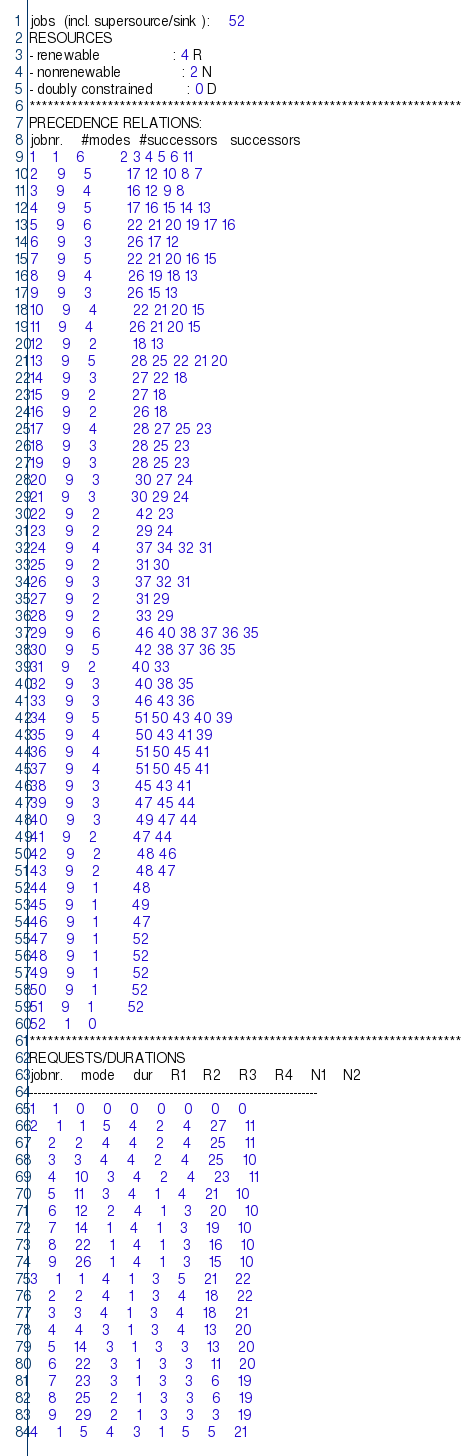Convert code to text. <code><loc_0><loc_0><loc_500><loc_500><_ObjectiveC_>jobs  (incl. supersource/sink ):	52
RESOURCES
- renewable                 : 4 R
- nonrenewable              : 2 N
- doubly constrained        : 0 D
************************************************************************
PRECEDENCE RELATIONS:
jobnr.    #modes  #successors   successors
1	1	6		2 3 4 5 6 11 
2	9	5		17 12 10 8 7 
3	9	4		16 12 9 8 
4	9	5		17 16 15 14 13 
5	9	6		22 21 20 19 17 16 
6	9	3		26 17 12 
7	9	5		22 21 20 16 15 
8	9	4		26 19 18 13 
9	9	3		26 15 13 
10	9	4		22 21 20 15 
11	9	4		26 21 20 15 
12	9	2		18 13 
13	9	5		28 25 22 21 20 
14	9	3		27 22 18 
15	9	2		27 18 
16	9	2		26 18 
17	9	4		28 27 25 23 
18	9	3		28 25 23 
19	9	3		28 25 23 
20	9	3		30 27 24 
21	9	3		30 29 24 
22	9	2		42 23 
23	9	2		29 24 
24	9	4		37 34 32 31 
25	9	2		31 30 
26	9	3		37 32 31 
27	9	2		31 29 
28	9	2		33 29 
29	9	6		46 40 38 37 36 35 
30	9	5		42 38 37 36 35 
31	9	2		40 33 
32	9	3		40 38 35 
33	9	3		46 43 36 
34	9	5		51 50 43 40 39 
35	9	4		50 43 41 39 
36	9	4		51 50 45 41 
37	9	4		51 50 45 41 
38	9	3		45 43 41 
39	9	3		47 45 44 
40	9	3		49 47 44 
41	9	2		47 44 
42	9	2		48 46 
43	9	2		48 47 
44	9	1		48 
45	9	1		49 
46	9	1		47 
47	9	1		52 
48	9	1		52 
49	9	1		52 
50	9	1		52 
51	9	1		52 
52	1	0		
************************************************************************
REQUESTS/DURATIONS
jobnr.	mode	dur	R1	R2	R3	R4	N1	N2	
------------------------------------------------------------------------
1	1	0	0	0	0	0	0	0	
2	1	1	5	4	2	4	27	11	
	2	2	4	4	2	4	25	11	
	3	3	4	4	2	4	25	10	
	4	10	3	4	2	4	23	11	
	5	11	3	4	1	4	21	10	
	6	12	2	4	1	3	20	10	
	7	14	1	4	1	3	19	10	
	8	22	1	4	1	3	16	10	
	9	26	1	4	1	3	15	10	
3	1	1	4	1	3	5	21	22	
	2	2	4	1	3	4	18	22	
	3	3	4	1	3	4	18	21	
	4	4	3	1	3	4	13	20	
	5	14	3	1	3	3	13	20	
	6	22	3	1	3	3	11	20	
	7	23	3	1	3	3	6	19	
	8	25	2	1	3	3	6	19	
	9	29	2	1	3	3	3	19	
4	1	5	4	3	1	5	5	21	</code> 